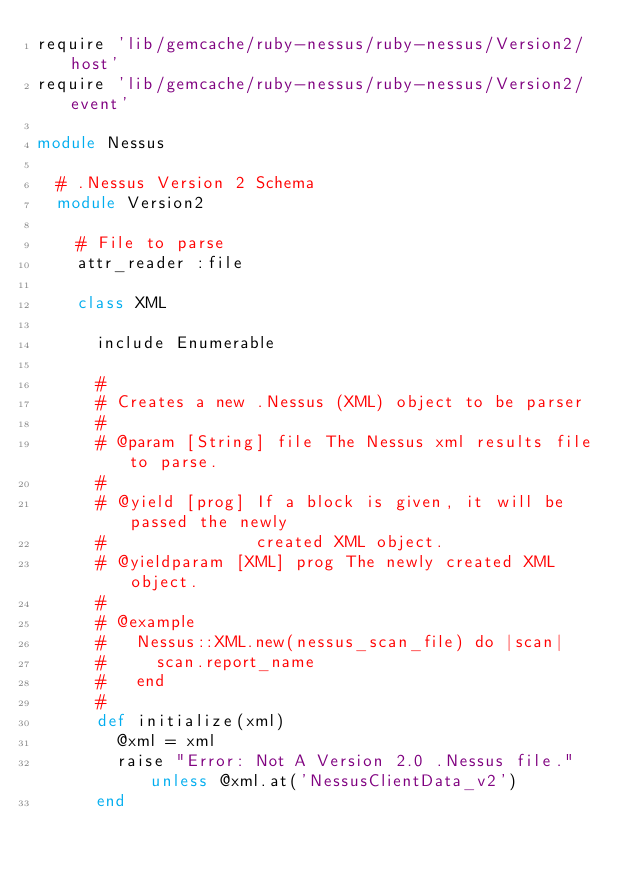Convert code to text. <code><loc_0><loc_0><loc_500><loc_500><_Ruby_>require 'lib/gemcache/ruby-nessus/ruby-nessus/Version2/host'
require 'lib/gemcache/ruby-nessus/ruby-nessus/Version2/event'

module Nessus
  
  # .Nessus Version 2 Schema
  module Version2

    # File to parse
    attr_reader :file

    class XML

      include Enumerable

      #
      # Creates a new .Nessus (XML) object to be parser
      #
      # @param [String] file The Nessus xml results file to parse.
      #
      # @yield [prog] If a block is given, it will be passed the newly
      #               created XML object.
      # @yieldparam [XML] prog The newly created XML object.
      #
      # @example
      #   Nessus::XML.new(nessus_scan_file) do |scan|
      #     scan.report_name
      #   end
      #
      def initialize(xml)
        @xml = xml
        raise "Error: Not A Version 2.0 .Nessus file." unless @xml.at('NessusClientData_v2')
      end
      </code> 